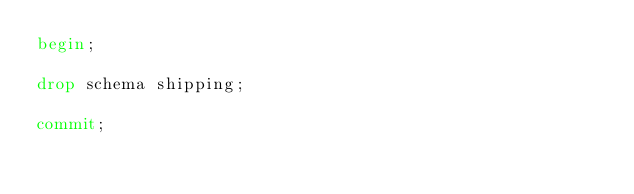<code> <loc_0><loc_0><loc_500><loc_500><_SQL_>begin;

drop schema shipping;

commit;
</code> 